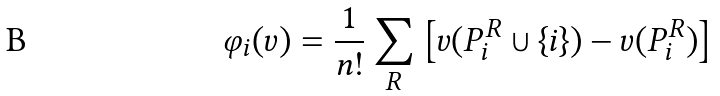<formula> <loc_0><loc_0><loc_500><loc_500>\varphi _ { i } ( v ) = { \frac { 1 } { n ! } } \sum _ { R } \left [ v ( P _ { i } ^ { R } \cup \left \{ i \right \} ) - v ( P _ { i } ^ { R } ) \right ]</formula> 